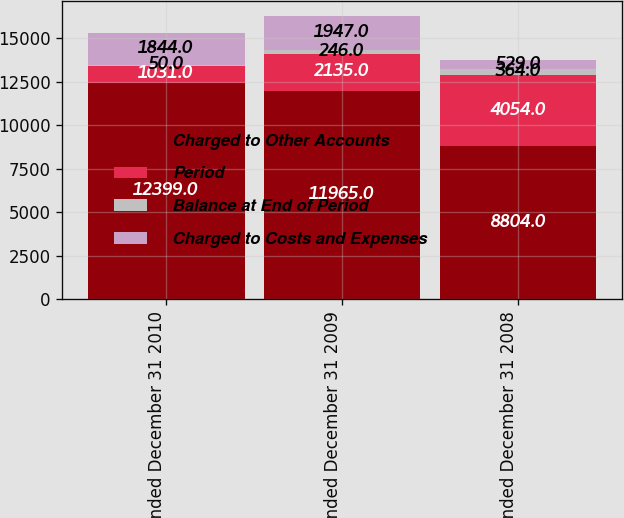Convert chart. <chart><loc_0><loc_0><loc_500><loc_500><stacked_bar_chart><ecel><fcel>Year ended December 31 2010<fcel>Year ended December 31 2009<fcel>Year ended December 31 2008<nl><fcel>Charged to Other Accounts<fcel>12399<fcel>11965<fcel>8804<nl><fcel>Period<fcel>1031<fcel>2135<fcel>4054<nl><fcel>Balance at End of Period<fcel>50<fcel>246<fcel>364<nl><fcel>Charged to Costs and Expenses<fcel>1844<fcel>1947<fcel>529<nl></chart> 